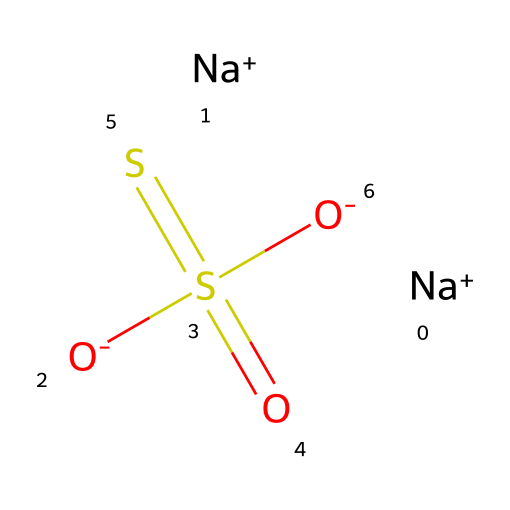What is the molecular formula of sodium thiosulfate? The SMILES representation includes two sodium ions, one sulfur atom in the center, and additional sulfur atoms and oxygen atoms, indicating the overall formula is Na2S2O3.
Answer: Na2S2O3 How many sulfur atoms are present in this compound? In the given SMILES, there are two sulfur atoms indicated by the notation 'S(=O)(=S)' which shows one central sulfur atom bonding with the second sulfur atom.
Answer: two What type of bond connects the sodium ions to the thiosulfate anion? The sodium ions are represented as 'Na+' and are ionically bonded to the negatively charged thiosulfate anion '[O-]S(=O)(=S)[O-]', indicating ionic bonds due to opposite charges.
Answer: ionic What is the oxidation state of the central sulfur atom in sodium thiosulfate? To determine the oxidation state, consider the overall neutral charge of the compound, negatively charged oxygen atoms, and the position of sulfur; here, the central sulfur atom has an oxidation state of +4.
Answer: +4 Is sodium thiosulfate a reducing agent? Given its chemical structure and properties, sodium thiosulfate can donate electrons to reduce other chemicals, confirming it acts as a reducing agent in various reactions.
Answer: yes How many oxygen atoms are there in sodium thiosulfate? The structure shows three oxygen atoms in total from the three '[O-]' groups surrounding the sulfur atoms, indicating the overall composition includes three oxygen atoms.
Answer: three What unique structural feature defines sodium thiosulfate among sulfur compounds? Sodium thiosulfate's unique feature is its combination of two sulfur atoms in a thiosulfate group, which differentiates it from other sulfur compounds, indicating its specific behavior in chemical reactions.
Answer: thiosulfate group 